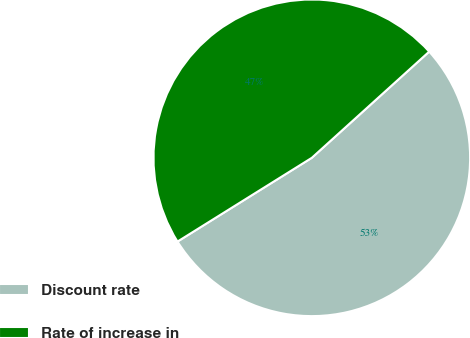Convert chart. <chart><loc_0><loc_0><loc_500><loc_500><pie_chart><fcel>Discount rate<fcel>Rate of increase in<nl><fcel>52.83%<fcel>47.17%<nl></chart> 